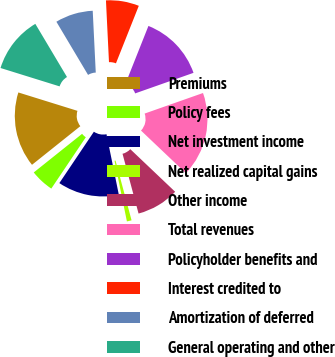Convert chart to OTSL. <chart><loc_0><loc_0><loc_500><loc_500><pie_chart><fcel>Premiums<fcel>Policy fees<fcel>Net investment income<fcel>Net realized capital gains<fcel>Other income<fcel>Total revenues<fcel>Policyholder benefits and<fcel>Interest credited to<fcel>Amortization of deferred<fcel>General operating and other<nl><fcel>15.53%<fcel>4.85%<fcel>12.62%<fcel>0.97%<fcel>8.74%<fcel>17.48%<fcel>13.59%<fcel>6.8%<fcel>7.77%<fcel>11.65%<nl></chart> 